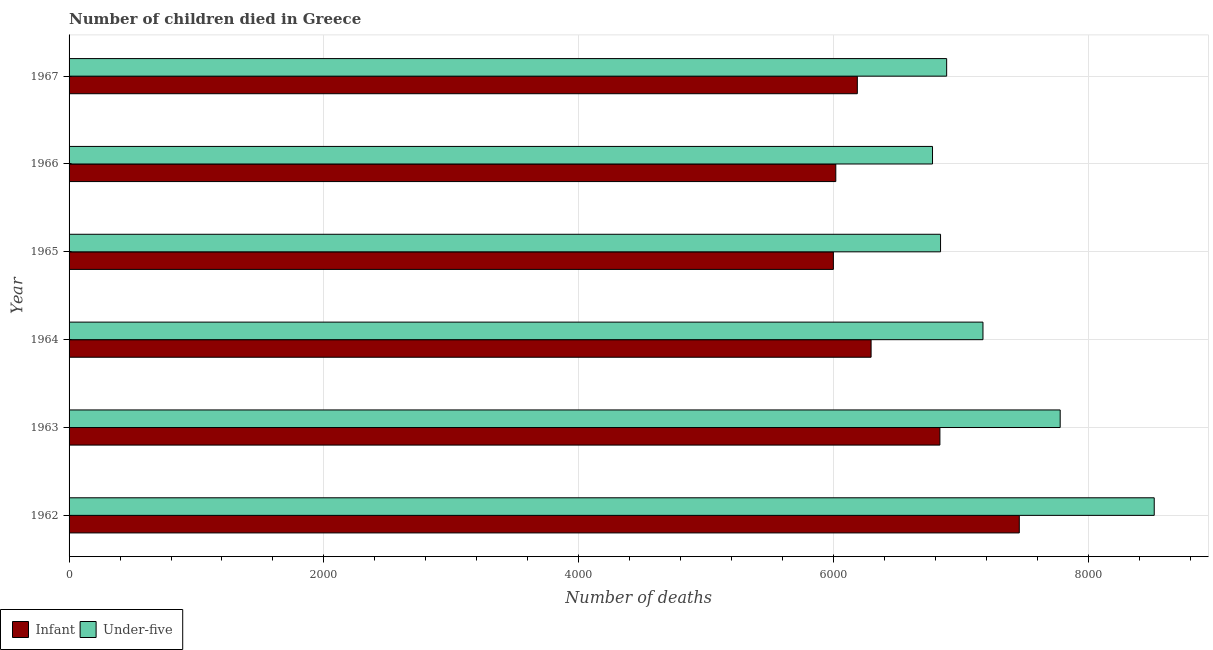Are the number of bars per tick equal to the number of legend labels?
Give a very brief answer. Yes. Are the number of bars on each tick of the Y-axis equal?
Your answer should be compact. Yes. How many bars are there on the 3rd tick from the top?
Keep it short and to the point. 2. In how many cases, is the number of bars for a given year not equal to the number of legend labels?
Keep it short and to the point. 0. What is the number of under-five deaths in 1965?
Make the answer very short. 6839. Across all years, what is the maximum number of infant deaths?
Provide a short and direct response. 7457. Across all years, what is the minimum number of infant deaths?
Your answer should be very brief. 5998. In which year was the number of infant deaths maximum?
Your answer should be very brief. 1962. In which year was the number of infant deaths minimum?
Your response must be concise. 1965. What is the total number of infant deaths in the graph?
Your response must be concise. 3.88e+04. What is the difference between the number of infant deaths in 1962 and that in 1964?
Keep it short and to the point. 1163. What is the difference between the number of under-five deaths in 1962 and the number of infant deaths in 1965?
Your answer should be very brief. 2518. What is the average number of infant deaths per year?
Ensure brevity in your answer.  6464.33. In the year 1965, what is the difference between the number of infant deaths and number of under-five deaths?
Make the answer very short. -841. In how many years, is the number of under-five deaths greater than 7600 ?
Keep it short and to the point. 2. What is the ratio of the number of under-five deaths in 1962 to that in 1966?
Your answer should be compact. 1.26. What is the difference between the highest and the second highest number of under-five deaths?
Offer a very short reply. 738. What is the difference between the highest and the lowest number of under-five deaths?
Offer a very short reply. 1740. Is the sum of the number of under-five deaths in 1962 and 1967 greater than the maximum number of infant deaths across all years?
Offer a terse response. Yes. What does the 2nd bar from the top in 1963 represents?
Keep it short and to the point. Infant. What does the 1st bar from the bottom in 1964 represents?
Provide a short and direct response. Infant. How many bars are there?
Your answer should be very brief. 12. Does the graph contain any zero values?
Your answer should be very brief. No. How are the legend labels stacked?
Your answer should be compact. Horizontal. What is the title of the graph?
Ensure brevity in your answer.  Number of children died in Greece. Does "Taxes on profits and capital gains" appear as one of the legend labels in the graph?
Your response must be concise. No. What is the label or title of the X-axis?
Your response must be concise. Number of deaths. What is the label or title of the Y-axis?
Give a very brief answer. Year. What is the Number of deaths in Infant in 1962?
Your answer should be compact. 7457. What is the Number of deaths of Under-five in 1962?
Make the answer very short. 8516. What is the Number of deaths in Infant in 1963?
Give a very brief answer. 6834. What is the Number of deaths in Under-five in 1963?
Offer a terse response. 7778. What is the Number of deaths in Infant in 1964?
Offer a terse response. 6294. What is the Number of deaths in Under-five in 1964?
Ensure brevity in your answer.  7172. What is the Number of deaths in Infant in 1965?
Provide a short and direct response. 5998. What is the Number of deaths of Under-five in 1965?
Your response must be concise. 6839. What is the Number of deaths of Infant in 1966?
Offer a terse response. 6017. What is the Number of deaths of Under-five in 1966?
Your answer should be compact. 6776. What is the Number of deaths in Infant in 1967?
Keep it short and to the point. 6186. What is the Number of deaths in Under-five in 1967?
Your answer should be compact. 6887. Across all years, what is the maximum Number of deaths in Infant?
Provide a succinct answer. 7457. Across all years, what is the maximum Number of deaths in Under-five?
Make the answer very short. 8516. Across all years, what is the minimum Number of deaths of Infant?
Your response must be concise. 5998. Across all years, what is the minimum Number of deaths of Under-five?
Offer a very short reply. 6776. What is the total Number of deaths in Infant in the graph?
Offer a very short reply. 3.88e+04. What is the total Number of deaths in Under-five in the graph?
Provide a short and direct response. 4.40e+04. What is the difference between the Number of deaths in Infant in 1962 and that in 1963?
Keep it short and to the point. 623. What is the difference between the Number of deaths in Under-five in 1962 and that in 1963?
Offer a very short reply. 738. What is the difference between the Number of deaths in Infant in 1962 and that in 1964?
Give a very brief answer. 1163. What is the difference between the Number of deaths in Under-five in 1962 and that in 1964?
Your answer should be compact. 1344. What is the difference between the Number of deaths of Infant in 1962 and that in 1965?
Keep it short and to the point. 1459. What is the difference between the Number of deaths in Under-five in 1962 and that in 1965?
Provide a succinct answer. 1677. What is the difference between the Number of deaths of Infant in 1962 and that in 1966?
Your answer should be very brief. 1440. What is the difference between the Number of deaths in Under-five in 1962 and that in 1966?
Offer a terse response. 1740. What is the difference between the Number of deaths of Infant in 1962 and that in 1967?
Offer a terse response. 1271. What is the difference between the Number of deaths of Under-five in 1962 and that in 1967?
Make the answer very short. 1629. What is the difference between the Number of deaths of Infant in 1963 and that in 1964?
Make the answer very short. 540. What is the difference between the Number of deaths of Under-five in 1963 and that in 1964?
Your response must be concise. 606. What is the difference between the Number of deaths in Infant in 1963 and that in 1965?
Give a very brief answer. 836. What is the difference between the Number of deaths of Under-five in 1963 and that in 1965?
Offer a very short reply. 939. What is the difference between the Number of deaths in Infant in 1963 and that in 1966?
Your answer should be compact. 817. What is the difference between the Number of deaths in Under-five in 1963 and that in 1966?
Ensure brevity in your answer.  1002. What is the difference between the Number of deaths in Infant in 1963 and that in 1967?
Make the answer very short. 648. What is the difference between the Number of deaths of Under-five in 1963 and that in 1967?
Offer a very short reply. 891. What is the difference between the Number of deaths of Infant in 1964 and that in 1965?
Give a very brief answer. 296. What is the difference between the Number of deaths of Under-five in 1964 and that in 1965?
Give a very brief answer. 333. What is the difference between the Number of deaths of Infant in 1964 and that in 1966?
Offer a very short reply. 277. What is the difference between the Number of deaths of Under-five in 1964 and that in 1966?
Ensure brevity in your answer.  396. What is the difference between the Number of deaths of Infant in 1964 and that in 1967?
Give a very brief answer. 108. What is the difference between the Number of deaths of Under-five in 1964 and that in 1967?
Ensure brevity in your answer.  285. What is the difference between the Number of deaths in Under-five in 1965 and that in 1966?
Give a very brief answer. 63. What is the difference between the Number of deaths in Infant in 1965 and that in 1967?
Your response must be concise. -188. What is the difference between the Number of deaths in Under-five in 1965 and that in 1967?
Offer a very short reply. -48. What is the difference between the Number of deaths in Infant in 1966 and that in 1967?
Make the answer very short. -169. What is the difference between the Number of deaths of Under-five in 1966 and that in 1967?
Offer a very short reply. -111. What is the difference between the Number of deaths in Infant in 1962 and the Number of deaths in Under-five in 1963?
Keep it short and to the point. -321. What is the difference between the Number of deaths of Infant in 1962 and the Number of deaths of Under-five in 1964?
Offer a very short reply. 285. What is the difference between the Number of deaths of Infant in 1962 and the Number of deaths of Under-five in 1965?
Provide a succinct answer. 618. What is the difference between the Number of deaths of Infant in 1962 and the Number of deaths of Under-five in 1966?
Make the answer very short. 681. What is the difference between the Number of deaths in Infant in 1962 and the Number of deaths in Under-five in 1967?
Your answer should be compact. 570. What is the difference between the Number of deaths in Infant in 1963 and the Number of deaths in Under-five in 1964?
Offer a terse response. -338. What is the difference between the Number of deaths of Infant in 1963 and the Number of deaths of Under-five in 1965?
Offer a terse response. -5. What is the difference between the Number of deaths of Infant in 1963 and the Number of deaths of Under-five in 1967?
Make the answer very short. -53. What is the difference between the Number of deaths in Infant in 1964 and the Number of deaths in Under-five in 1965?
Keep it short and to the point. -545. What is the difference between the Number of deaths of Infant in 1964 and the Number of deaths of Under-five in 1966?
Your response must be concise. -482. What is the difference between the Number of deaths in Infant in 1964 and the Number of deaths in Under-five in 1967?
Ensure brevity in your answer.  -593. What is the difference between the Number of deaths in Infant in 1965 and the Number of deaths in Under-five in 1966?
Ensure brevity in your answer.  -778. What is the difference between the Number of deaths of Infant in 1965 and the Number of deaths of Under-five in 1967?
Offer a very short reply. -889. What is the difference between the Number of deaths of Infant in 1966 and the Number of deaths of Under-five in 1967?
Your answer should be very brief. -870. What is the average Number of deaths of Infant per year?
Give a very brief answer. 6464.33. What is the average Number of deaths in Under-five per year?
Provide a short and direct response. 7328. In the year 1962, what is the difference between the Number of deaths of Infant and Number of deaths of Under-five?
Your response must be concise. -1059. In the year 1963, what is the difference between the Number of deaths in Infant and Number of deaths in Under-five?
Provide a short and direct response. -944. In the year 1964, what is the difference between the Number of deaths of Infant and Number of deaths of Under-five?
Your answer should be very brief. -878. In the year 1965, what is the difference between the Number of deaths of Infant and Number of deaths of Under-five?
Provide a succinct answer. -841. In the year 1966, what is the difference between the Number of deaths of Infant and Number of deaths of Under-five?
Offer a terse response. -759. In the year 1967, what is the difference between the Number of deaths of Infant and Number of deaths of Under-five?
Ensure brevity in your answer.  -701. What is the ratio of the Number of deaths of Infant in 1962 to that in 1963?
Offer a terse response. 1.09. What is the ratio of the Number of deaths of Under-five in 1962 to that in 1963?
Your answer should be very brief. 1.09. What is the ratio of the Number of deaths in Infant in 1962 to that in 1964?
Ensure brevity in your answer.  1.18. What is the ratio of the Number of deaths of Under-five in 1962 to that in 1964?
Give a very brief answer. 1.19. What is the ratio of the Number of deaths in Infant in 1962 to that in 1965?
Offer a terse response. 1.24. What is the ratio of the Number of deaths in Under-five in 1962 to that in 1965?
Provide a short and direct response. 1.25. What is the ratio of the Number of deaths in Infant in 1962 to that in 1966?
Your response must be concise. 1.24. What is the ratio of the Number of deaths of Under-five in 1962 to that in 1966?
Ensure brevity in your answer.  1.26. What is the ratio of the Number of deaths of Infant in 1962 to that in 1967?
Ensure brevity in your answer.  1.21. What is the ratio of the Number of deaths of Under-five in 1962 to that in 1967?
Offer a very short reply. 1.24. What is the ratio of the Number of deaths in Infant in 1963 to that in 1964?
Make the answer very short. 1.09. What is the ratio of the Number of deaths of Under-five in 1963 to that in 1964?
Make the answer very short. 1.08. What is the ratio of the Number of deaths in Infant in 1963 to that in 1965?
Provide a succinct answer. 1.14. What is the ratio of the Number of deaths of Under-five in 1963 to that in 1965?
Give a very brief answer. 1.14. What is the ratio of the Number of deaths of Infant in 1963 to that in 1966?
Your answer should be very brief. 1.14. What is the ratio of the Number of deaths in Under-five in 1963 to that in 1966?
Offer a very short reply. 1.15. What is the ratio of the Number of deaths in Infant in 1963 to that in 1967?
Your response must be concise. 1.1. What is the ratio of the Number of deaths in Under-five in 1963 to that in 1967?
Provide a short and direct response. 1.13. What is the ratio of the Number of deaths of Infant in 1964 to that in 1965?
Ensure brevity in your answer.  1.05. What is the ratio of the Number of deaths in Under-five in 1964 to that in 1965?
Provide a succinct answer. 1.05. What is the ratio of the Number of deaths of Infant in 1964 to that in 1966?
Offer a very short reply. 1.05. What is the ratio of the Number of deaths in Under-five in 1964 to that in 1966?
Make the answer very short. 1.06. What is the ratio of the Number of deaths in Infant in 1964 to that in 1967?
Ensure brevity in your answer.  1.02. What is the ratio of the Number of deaths in Under-five in 1964 to that in 1967?
Your response must be concise. 1.04. What is the ratio of the Number of deaths in Infant in 1965 to that in 1966?
Your answer should be very brief. 1. What is the ratio of the Number of deaths in Under-five in 1965 to that in 1966?
Provide a succinct answer. 1.01. What is the ratio of the Number of deaths of Infant in 1965 to that in 1967?
Keep it short and to the point. 0.97. What is the ratio of the Number of deaths in Under-five in 1965 to that in 1967?
Keep it short and to the point. 0.99. What is the ratio of the Number of deaths of Infant in 1966 to that in 1967?
Your answer should be compact. 0.97. What is the ratio of the Number of deaths in Under-five in 1966 to that in 1967?
Offer a terse response. 0.98. What is the difference between the highest and the second highest Number of deaths of Infant?
Offer a very short reply. 623. What is the difference between the highest and the second highest Number of deaths of Under-five?
Provide a short and direct response. 738. What is the difference between the highest and the lowest Number of deaths in Infant?
Provide a short and direct response. 1459. What is the difference between the highest and the lowest Number of deaths in Under-five?
Ensure brevity in your answer.  1740. 